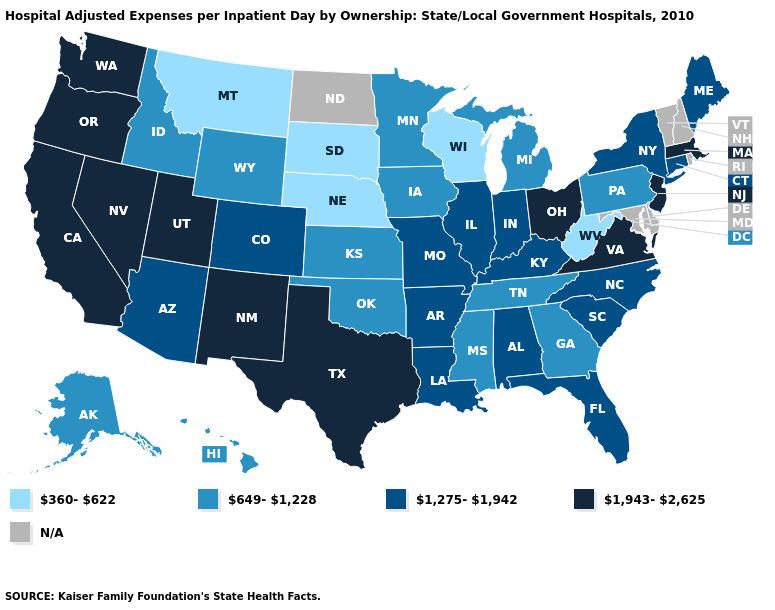Which states hav the highest value in the MidWest?
Be succinct. Ohio. How many symbols are there in the legend?
Short answer required. 5. Among the states that border Illinois , does Wisconsin have the lowest value?
Short answer required. Yes. What is the highest value in the USA?
Be succinct. 1,943-2,625. What is the highest value in the Northeast ?
Answer briefly. 1,943-2,625. What is the value of Idaho?
Give a very brief answer. 649-1,228. What is the value of Iowa?
Quick response, please. 649-1,228. What is the highest value in states that border Georgia?
Be succinct. 1,275-1,942. What is the highest value in the MidWest ?
Write a very short answer. 1,943-2,625. What is the value of Oklahoma?
Quick response, please. 649-1,228. Does the first symbol in the legend represent the smallest category?
Write a very short answer. Yes. Among the states that border Kansas , does Colorado have the lowest value?
Concise answer only. No. Name the states that have a value in the range 1,943-2,625?
Write a very short answer. California, Massachusetts, Nevada, New Jersey, New Mexico, Ohio, Oregon, Texas, Utah, Virginia, Washington. Among the states that border Florida , does Alabama have the lowest value?
Concise answer only. No. 